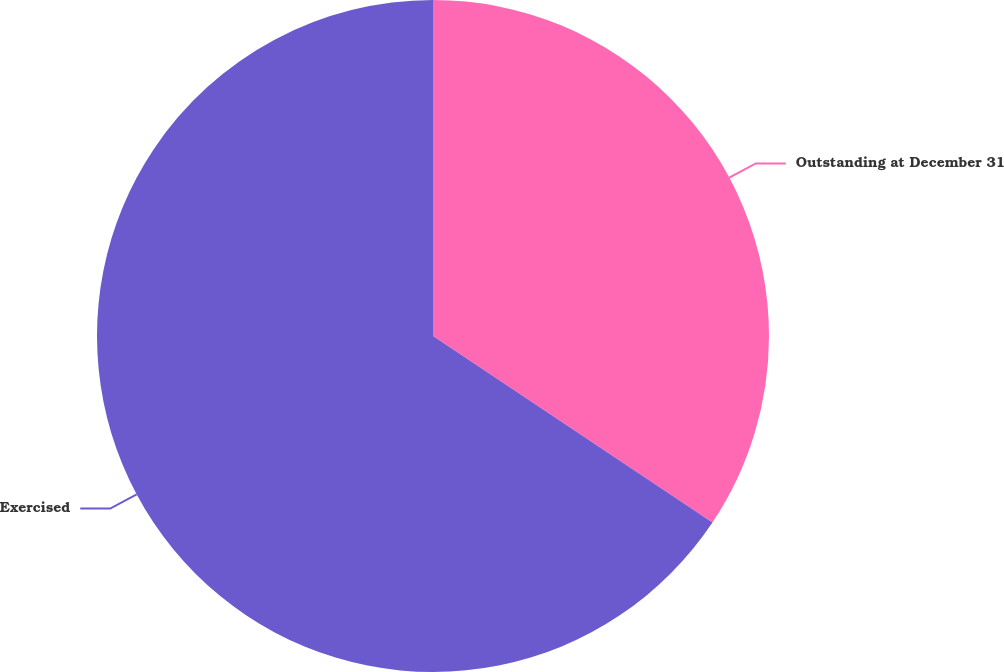Convert chart to OTSL. <chart><loc_0><loc_0><loc_500><loc_500><pie_chart><fcel>Outstanding at December 31<fcel>Exercised<nl><fcel>34.37%<fcel>65.63%<nl></chart> 